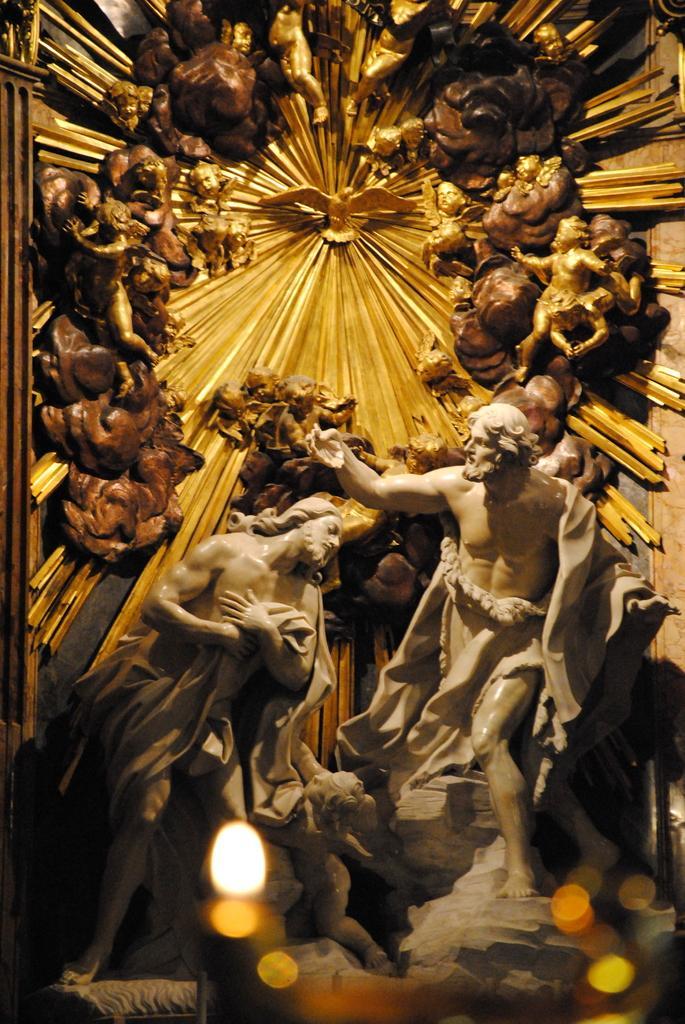Please provide a concise description of this image. In this image we can see the statues and a group of sculptures. 